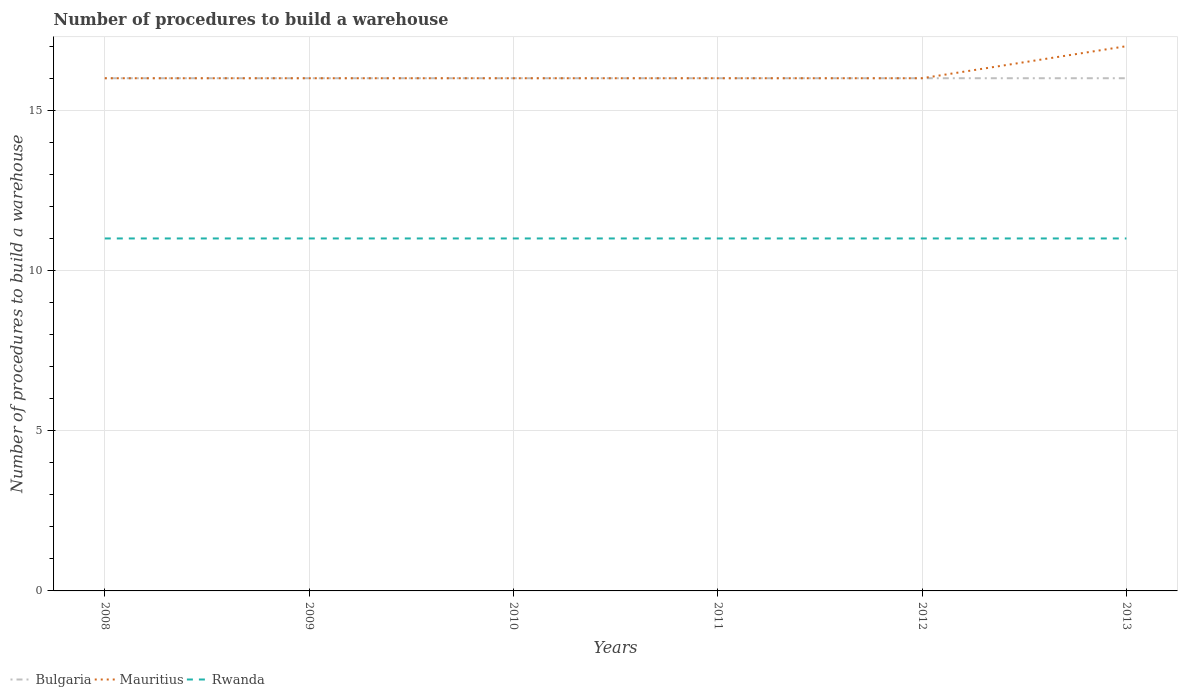Across all years, what is the maximum number of procedures to build a warehouse in in Mauritius?
Your response must be concise. 16. In which year was the number of procedures to build a warehouse in in Mauritius maximum?
Ensure brevity in your answer.  2008. What is the total number of procedures to build a warehouse in in Bulgaria in the graph?
Your response must be concise. 0. What is the difference between the highest and the second highest number of procedures to build a warehouse in in Mauritius?
Your answer should be compact. 1. How many lines are there?
Provide a succinct answer. 3. What is the difference between two consecutive major ticks on the Y-axis?
Give a very brief answer. 5. Does the graph contain any zero values?
Your answer should be compact. No. Does the graph contain grids?
Your answer should be very brief. Yes. Where does the legend appear in the graph?
Keep it short and to the point. Bottom left. How many legend labels are there?
Your answer should be very brief. 3. How are the legend labels stacked?
Offer a terse response. Horizontal. What is the title of the graph?
Keep it short and to the point. Number of procedures to build a warehouse. What is the label or title of the X-axis?
Keep it short and to the point. Years. What is the label or title of the Y-axis?
Provide a succinct answer. Number of procedures to build a warehouse. What is the Number of procedures to build a warehouse in Bulgaria in 2009?
Offer a very short reply. 16. What is the Number of procedures to build a warehouse of Rwanda in 2009?
Make the answer very short. 11. What is the Number of procedures to build a warehouse of Bulgaria in 2010?
Provide a short and direct response. 16. What is the Number of procedures to build a warehouse of Mauritius in 2010?
Offer a terse response. 16. What is the Number of procedures to build a warehouse in Bulgaria in 2011?
Your response must be concise. 16. What is the Number of procedures to build a warehouse of Bulgaria in 2012?
Your answer should be very brief. 16. What is the Number of procedures to build a warehouse in Mauritius in 2012?
Offer a very short reply. 16. What is the Number of procedures to build a warehouse in Rwanda in 2012?
Offer a terse response. 11. What is the Number of procedures to build a warehouse of Bulgaria in 2013?
Make the answer very short. 16. What is the Number of procedures to build a warehouse in Mauritius in 2013?
Provide a short and direct response. 17. What is the Number of procedures to build a warehouse in Rwanda in 2013?
Ensure brevity in your answer.  11. Across all years, what is the maximum Number of procedures to build a warehouse in Mauritius?
Provide a short and direct response. 17. Across all years, what is the maximum Number of procedures to build a warehouse of Rwanda?
Your answer should be compact. 11. Across all years, what is the minimum Number of procedures to build a warehouse in Bulgaria?
Your response must be concise. 16. What is the total Number of procedures to build a warehouse in Bulgaria in the graph?
Give a very brief answer. 96. What is the total Number of procedures to build a warehouse of Mauritius in the graph?
Offer a terse response. 97. What is the difference between the Number of procedures to build a warehouse in Bulgaria in 2008 and that in 2010?
Ensure brevity in your answer.  0. What is the difference between the Number of procedures to build a warehouse in Rwanda in 2008 and that in 2011?
Your answer should be very brief. 0. What is the difference between the Number of procedures to build a warehouse in Bulgaria in 2008 and that in 2012?
Your answer should be very brief. 0. What is the difference between the Number of procedures to build a warehouse in Rwanda in 2008 and that in 2012?
Offer a very short reply. 0. What is the difference between the Number of procedures to build a warehouse in Bulgaria in 2008 and that in 2013?
Keep it short and to the point. 0. What is the difference between the Number of procedures to build a warehouse in Mauritius in 2008 and that in 2013?
Provide a succinct answer. -1. What is the difference between the Number of procedures to build a warehouse in Rwanda in 2008 and that in 2013?
Offer a terse response. 0. What is the difference between the Number of procedures to build a warehouse in Mauritius in 2009 and that in 2010?
Your answer should be very brief. 0. What is the difference between the Number of procedures to build a warehouse in Mauritius in 2009 and that in 2011?
Provide a short and direct response. 0. What is the difference between the Number of procedures to build a warehouse of Rwanda in 2009 and that in 2011?
Make the answer very short. 0. What is the difference between the Number of procedures to build a warehouse of Bulgaria in 2009 and that in 2012?
Make the answer very short. 0. What is the difference between the Number of procedures to build a warehouse of Mauritius in 2009 and that in 2013?
Give a very brief answer. -1. What is the difference between the Number of procedures to build a warehouse in Bulgaria in 2010 and that in 2011?
Provide a short and direct response. 0. What is the difference between the Number of procedures to build a warehouse in Mauritius in 2010 and that in 2011?
Your answer should be compact. 0. What is the difference between the Number of procedures to build a warehouse of Rwanda in 2010 and that in 2011?
Offer a very short reply. 0. What is the difference between the Number of procedures to build a warehouse in Mauritius in 2010 and that in 2012?
Keep it short and to the point. 0. What is the difference between the Number of procedures to build a warehouse of Rwanda in 2010 and that in 2012?
Give a very brief answer. 0. What is the difference between the Number of procedures to build a warehouse of Bulgaria in 2010 and that in 2013?
Offer a terse response. 0. What is the difference between the Number of procedures to build a warehouse in Rwanda in 2010 and that in 2013?
Make the answer very short. 0. What is the difference between the Number of procedures to build a warehouse in Mauritius in 2011 and that in 2012?
Provide a succinct answer. 0. What is the difference between the Number of procedures to build a warehouse in Bulgaria in 2011 and that in 2013?
Offer a very short reply. 0. What is the difference between the Number of procedures to build a warehouse of Rwanda in 2011 and that in 2013?
Make the answer very short. 0. What is the difference between the Number of procedures to build a warehouse in Mauritius in 2012 and that in 2013?
Your answer should be compact. -1. What is the difference between the Number of procedures to build a warehouse in Rwanda in 2012 and that in 2013?
Offer a terse response. 0. What is the difference between the Number of procedures to build a warehouse of Bulgaria in 2008 and the Number of procedures to build a warehouse of Mauritius in 2009?
Your response must be concise. 0. What is the difference between the Number of procedures to build a warehouse in Mauritius in 2008 and the Number of procedures to build a warehouse in Rwanda in 2009?
Ensure brevity in your answer.  5. What is the difference between the Number of procedures to build a warehouse in Bulgaria in 2008 and the Number of procedures to build a warehouse in Mauritius in 2010?
Keep it short and to the point. 0. What is the difference between the Number of procedures to build a warehouse in Mauritius in 2008 and the Number of procedures to build a warehouse in Rwanda in 2010?
Give a very brief answer. 5. What is the difference between the Number of procedures to build a warehouse of Mauritius in 2008 and the Number of procedures to build a warehouse of Rwanda in 2011?
Your response must be concise. 5. What is the difference between the Number of procedures to build a warehouse in Bulgaria in 2008 and the Number of procedures to build a warehouse in Mauritius in 2012?
Keep it short and to the point. 0. What is the difference between the Number of procedures to build a warehouse in Mauritius in 2008 and the Number of procedures to build a warehouse in Rwanda in 2012?
Your answer should be compact. 5. What is the difference between the Number of procedures to build a warehouse in Bulgaria in 2009 and the Number of procedures to build a warehouse in Mauritius in 2010?
Keep it short and to the point. 0. What is the difference between the Number of procedures to build a warehouse in Bulgaria in 2009 and the Number of procedures to build a warehouse in Mauritius in 2011?
Your answer should be compact. 0. What is the difference between the Number of procedures to build a warehouse of Bulgaria in 2009 and the Number of procedures to build a warehouse of Rwanda in 2011?
Keep it short and to the point. 5. What is the difference between the Number of procedures to build a warehouse in Bulgaria in 2009 and the Number of procedures to build a warehouse in Mauritius in 2012?
Keep it short and to the point. 0. What is the difference between the Number of procedures to build a warehouse of Mauritius in 2009 and the Number of procedures to build a warehouse of Rwanda in 2012?
Offer a terse response. 5. What is the difference between the Number of procedures to build a warehouse of Bulgaria in 2009 and the Number of procedures to build a warehouse of Mauritius in 2013?
Ensure brevity in your answer.  -1. What is the difference between the Number of procedures to build a warehouse of Bulgaria in 2009 and the Number of procedures to build a warehouse of Rwanda in 2013?
Make the answer very short. 5. What is the difference between the Number of procedures to build a warehouse in Bulgaria in 2010 and the Number of procedures to build a warehouse in Mauritius in 2011?
Your answer should be compact. 0. What is the difference between the Number of procedures to build a warehouse in Bulgaria in 2010 and the Number of procedures to build a warehouse in Rwanda in 2011?
Offer a terse response. 5. What is the difference between the Number of procedures to build a warehouse of Bulgaria in 2010 and the Number of procedures to build a warehouse of Rwanda in 2012?
Make the answer very short. 5. What is the difference between the Number of procedures to build a warehouse in Mauritius in 2010 and the Number of procedures to build a warehouse in Rwanda in 2012?
Offer a very short reply. 5. What is the difference between the Number of procedures to build a warehouse in Bulgaria in 2010 and the Number of procedures to build a warehouse in Mauritius in 2013?
Provide a succinct answer. -1. What is the difference between the Number of procedures to build a warehouse in Bulgaria in 2011 and the Number of procedures to build a warehouse in Mauritius in 2012?
Offer a terse response. 0. What is the difference between the Number of procedures to build a warehouse of Bulgaria in 2012 and the Number of procedures to build a warehouse of Mauritius in 2013?
Provide a succinct answer. -1. What is the difference between the Number of procedures to build a warehouse in Mauritius in 2012 and the Number of procedures to build a warehouse in Rwanda in 2013?
Provide a succinct answer. 5. What is the average Number of procedures to build a warehouse in Bulgaria per year?
Offer a terse response. 16. What is the average Number of procedures to build a warehouse in Mauritius per year?
Your answer should be very brief. 16.17. In the year 2008, what is the difference between the Number of procedures to build a warehouse in Bulgaria and Number of procedures to build a warehouse in Mauritius?
Make the answer very short. 0. In the year 2008, what is the difference between the Number of procedures to build a warehouse of Bulgaria and Number of procedures to build a warehouse of Rwanda?
Offer a terse response. 5. In the year 2009, what is the difference between the Number of procedures to build a warehouse of Bulgaria and Number of procedures to build a warehouse of Mauritius?
Provide a short and direct response. 0. In the year 2009, what is the difference between the Number of procedures to build a warehouse of Mauritius and Number of procedures to build a warehouse of Rwanda?
Your answer should be very brief. 5. In the year 2010, what is the difference between the Number of procedures to build a warehouse in Bulgaria and Number of procedures to build a warehouse in Mauritius?
Make the answer very short. 0. In the year 2010, what is the difference between the Number of procedures to build a warehouse of Bulgaria and Number of procedures to build a warehouse of Rwanda?
Offer a terse response. 5. In the year 2010, what is the difference between the Number of procedures to build a warehouse in Mauritius and Number of procedures to build a warehouse in Rwanda?
Your answer should be very brief. 5. In the year 2011, what is the difference between the Number of procedures to build a warehouse in Bulgaria and Number of procedures to build a warehouse in Mauritius?
Offer a terse response. 0. In the year 2011, what is the difference between the Number of procedures to build a warehouse of Bulgaria and Number of procedures to build a warehouse of Rwanda?
Offer a terse response. 5. In the year 2011, what is the difference between the Number of procedures to build a warehouse of Mauritius and Number of procedures to build a warehouse of Rwanda?
Ensure brevity in your answer.  5. In the year 2012, what is the difference between the Number of procedures to build a warehouse of Bulgaria and Number of procedures to build a warehouse of Rwanda?
Ensure brevity in your answer.  5. In the year 2013, what is the difference between the Number of procedures to build a warehouse of Bulgaria and Number of procedures to build a warehouse of Rwanda?
Make the answer very short. 5. In the year 2013, what is the difference between the Number of procedures to build a warehouse of Mauritius and Number of procedures to build a warehouse of Rwanda?
Offer a very short reply. 6. What is the ratio of the Number of procedures to build a warehouse of Bulgaria in 2008 to that in 2009?
Offer a terse response. 1. What is the ratio of the Number of procedures to build a warehouse in Mauritius in 2008 to that in 2010?
Your answer should be very brief. 1. What is the ratio of the Number of procedures to build a warehouse in Rwanda in 2008 to that in 2011?
Provide a succinct answer. 1. What is the ratio of the Number of procedures to build a warehouse of Mauritius in 2008 to that in 2012?
Ensure brevity in your answer.  1. What is the ratio of the Number of procedures to build a warehouse of Rwanda in 2008 to that in 2012?
Your answer should be very brief. 1. What is the ratio of the Number of procedures to build a warehouse in Rwanda in 2008 to that in 2013?
Ensure brevity in your answer.  1. What is the ratio of the Number of procedures to build a warehouse of Bulgaria in 2009 to that in 2010?
Provide a succinct answer. 1. What is the ratio of the Number of procedures to build a warehouse of Rwanda in 2009 to that in 2011?
Your response must be concise. 1. What is the ratio of the Number of procedures to build a warehouse of Bulgaria in 2009 to that in 2012?
Make the answer very short. 1. What is the ratio of the Number of procedures to build a warehouse in Bulgaria in 2009 to that in 2013?
Your response must be concise. 1. What is the ratio of the Number of procedures to build a warehouse in Rwanda in 2009 to that in 2013?
Keep it short and to the point. 1. What is the ratio of the Number of procedures to build a warehouse in Bulgaria in 2010 to that in 2011?
Offer a very short reply. 1. What is the ratio of the Number of procedures to build a warehouse of Rwanda in 2010 to that in 2011?
Give a very brief answer. 1. What is the ratio of the Number of procedures to build a warehouse of Bulgaria in 2010 to that in 2012?
Give a very brief answer. 1. What is the ratio of the Number of procedures to build a warehouse in Rwanda in 2010 to that in 2012?
Your response must be concise. 1. What is the ratio of the Number of procedures to build a warehouse of Bulgaria in 2010 to that in 2013?
Offer a very short reply. 1. What is the ratio of the Number of procedures to build a warehouse in Rwanda in 2010 to that in 2013?
Make the answer very short. 1. What is the ratio of the Number of procedures to build a warehouse in Rwanda in 2011 to that in 2012?
Provide a short and direct response. 1. What is the ratio of the Number of procedures to build a warehouse of Mauritius in 2011 to that in 2013?
Give a very brief answer. 0.94. What is the ratio of the Number of procedures to build a warehouse of Rwanda in 2011 to that in 2013?
Ensure brevity in your answer.  1. What is the ratio of the Number of procedures to build a warehouse of Mauritius in 2012 to that in 2013?
Your response must be concise. 0.94. What is the ratio of the Number of procedures to build a warehouse in Rwanda in 2012 to that in 2013?
Make the answer very short. 1. What is the difference between the highest and the second highest Number of procedures to build a warehouse of Bulgaria?
Provide a short and direct response. 0. What is the difference between the highest and the second highest Number of procedures to build a warehouse of Mauritius?
Provide a short and direct response. 1. What is the difference between the highest and the second highest Number of procedures to build a warehouse in Rwanda?
Offer a very short reply. 0. What is the difference between the highest and the lowest Number of procedures to build a warehouse of Bulgaria?
Your answer should be compact. 0. What is the difference between the highest and the lowest Number of procedures to build a warehouse of Mauritius?
Your answer should be compact. 1. 